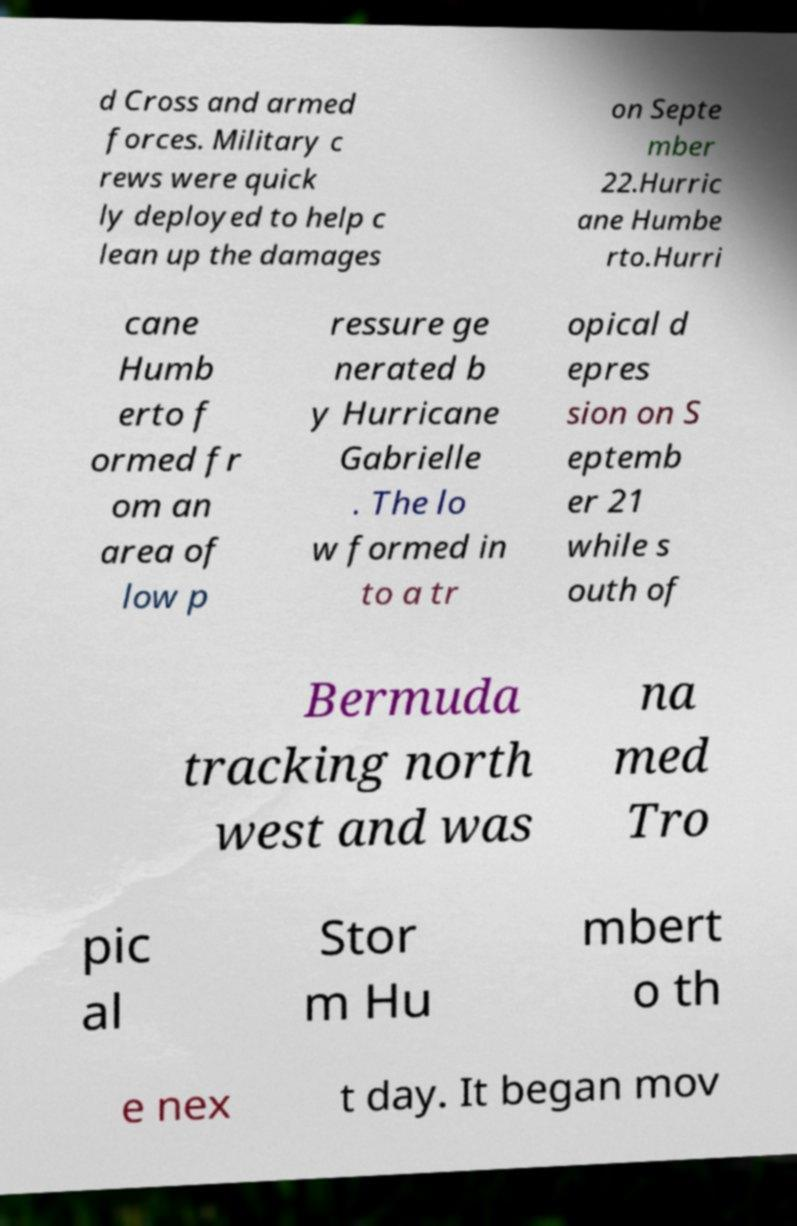I need the written content from this picture converted into text. Can you do that? d Cross and armed forces. Military c rews were quick ly deployed to help c lean up the damages on Septe mber 22.Hurric ane Humbe rto.Hurri cane Humb erto f ormed fr om an area of low p ressure ge nerated b y Hurricane Gabrielle . The lo w formed in to a tr opical d epres sion on S eptemb er 21 while s outh of Bermuda tracking north west and was na med Tro pic al Stor m Hu mbert o th e nex t day. It began mov 